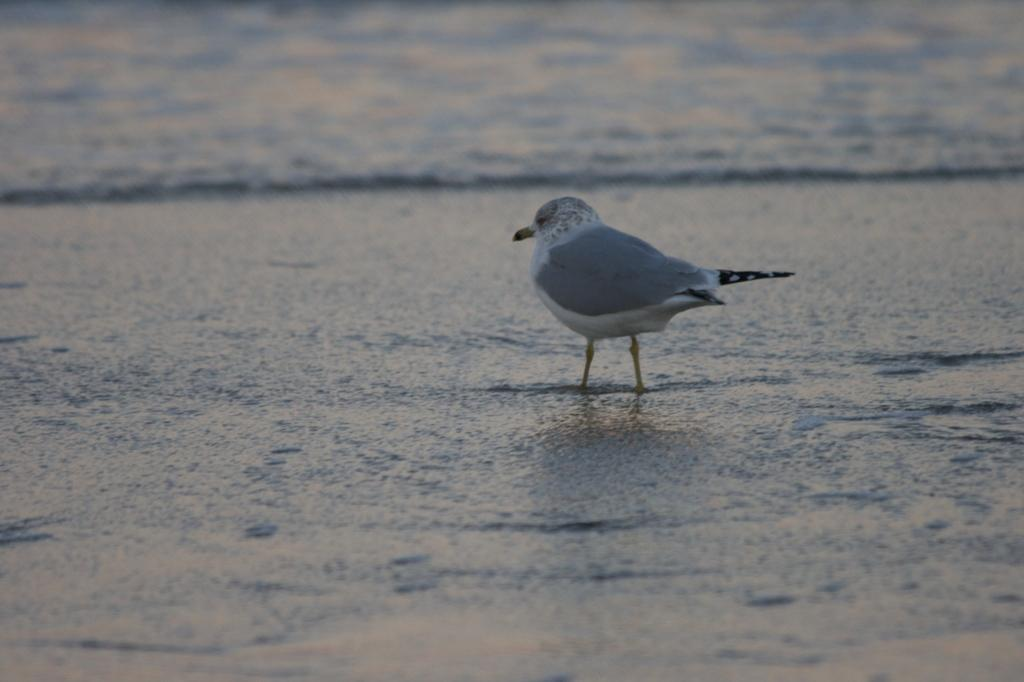What type of animal can be seen in the image? There is a bird in the image. What can be seen in the background of the image? There is water visible in the background of the image. What question is the bird asking in the image? There is no indication in the image that the bird is asking a question, as birds do not have the ability to ask questions. 